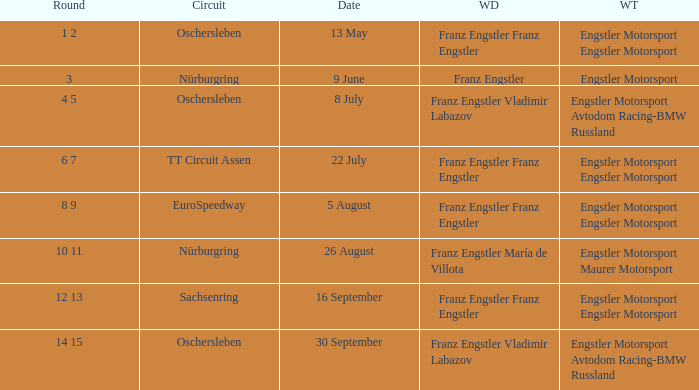With a Date of 22 July, what is the Winning team? Engstler Motorsport Engstler Motorsport. 